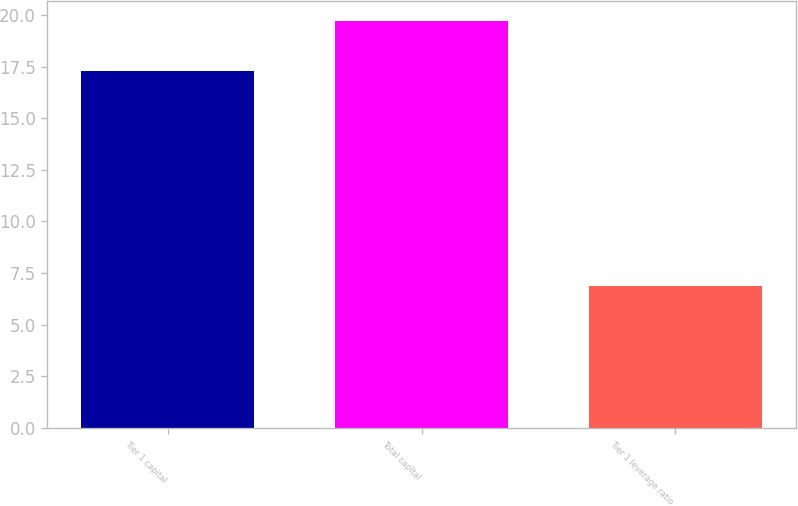<chart> <loc_0><loc_0><loc_500><loc_500><bar_chart><fcel>Tier 1 capital<fcel>Total capital<fcel>Tier 1 leverage ratio<nl><fcel>17.3<fcel>19.7<fcel>6.9<nl></chart> 